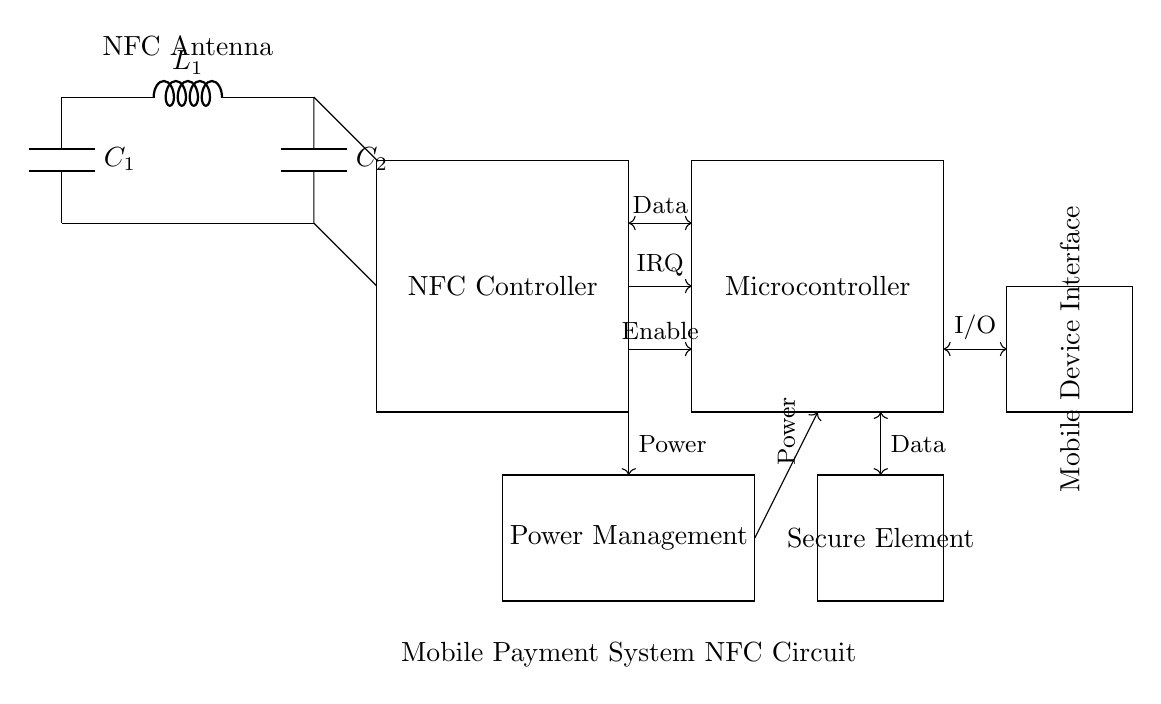What type of component is L1? L1 is an inductor, which is identified by the "L" designation in the circuit. Inductors are used in NFC circuits for filtering and resonance purposes.
Answer: Inductor What is the purpose of the Secure Element? The Secure Element is responsible for securely storing sensitive data such as cryptographic keys and payment information in mobile payment systems. This ensures that transactions are secure and protected from tampering.
Answer: Secure storage How many capacitors are present in the circuit? There are two capacitors, C1 and C2, in the circuit, indicated by the "C" designations next to their labels. Capacitors are essential for storing and managing electrical energy, especially in NFC applications.
Answer: Two What is the function of the IRQ line from the NFC Controller? The IRQ line (Interrupt Request) signals the microcontroller that the NFC Controller requires attention for processing data or events. This communication is crucial for the response time of the system.
Answer: To signal interrupts Which component receives power from the Power Management block? The NFC Controller receives power from the Power Management block as indicated by the power connection drawn between them. This is necessary for the NFC Controller to operate effectively in contactless transactions.
Answer: NFC Controller What type of diagram is this? This is a schematic diagram, which visually represents the components and their connections in an electronic circuit, facilitating understanding and design testing.
Answer: Schematic diagram 